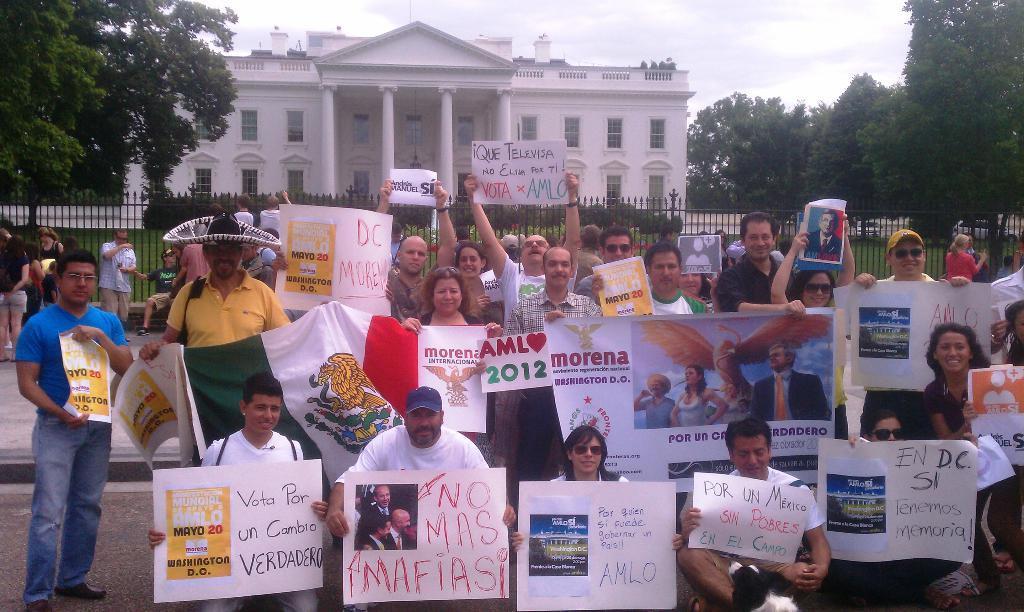In one or two sentences, can you explain what this image depicts? Front these group of people are holding posters and flag. Background there is a building with windows, trees, plants and fence. 